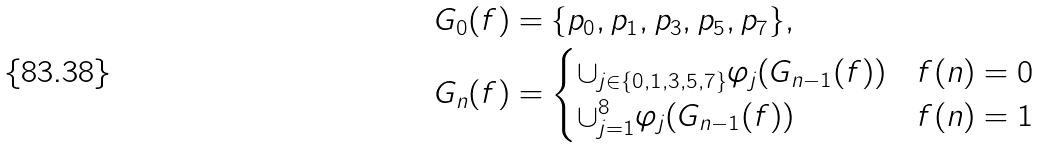<formula> <loc_0><loc_0><loc_500><loc_500>G _ { 0 } ( f ) & = \{ p _ { 0 } , p _ { 1 } , p _ { 3 } , p _ { 5 } , p _ { 7 } \} , \\ G _ { n } ( f ) & = \begin{cases} \cup _ { j \in \{ 0 , 1 , 3 , 5 , 7 \} } \varphi _ { j } ( G _ { n - 1 } ( f ) ) & f ( n ) = 0 \\ \cup _ { j = 1 } ^ { 8 } \varphi _ { j } ( G _ { n - 1 } ( f ) ) & f ( n ) = 1 \end{cases}</formula> 